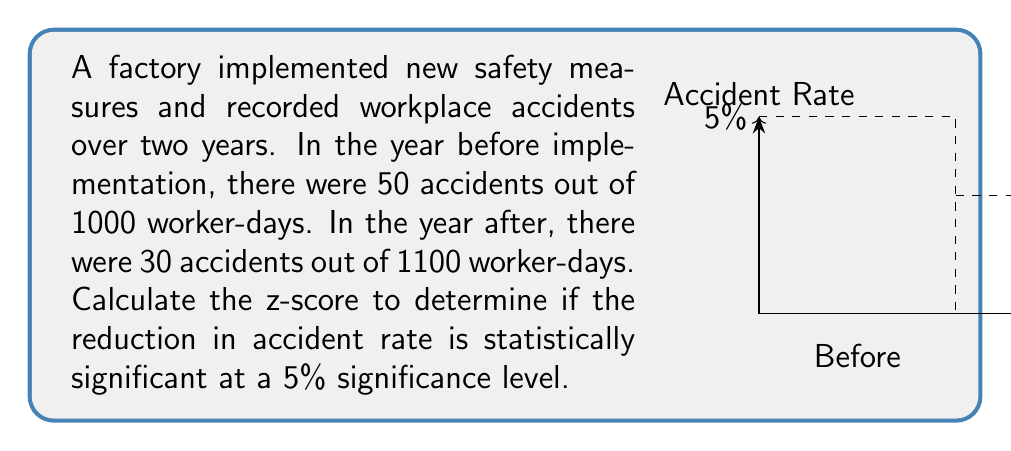Help me with this question. To determine if the reduction in accident rate is statistically significant, we'll use a z-test for the difference between two proportions.

Step 1: Calculate the proportions
$p_1 = 50/1000 = 0.05$ (before)
$p_2 = 30/1100 \approx 0.0273$ (after)

Step 2: Calculate the pooled proportion
$$p = \frac{50 + 30}{1000 + 1100} \approx 0.0381$$

Step 3: Calculate the standard error
$$SE = \sqrt{p(1-p)(\frac{1}{1000} + \frac{1}{1100})} \approx 0.00812$$

Step 4: Calculate the z-score
$$z = \frac{p_1 - p_2}{SE} = \frac{0.05 - 0.0273}{0.00812} \approx 2.795$$

Step 5: Compare with critical value
For a 5% significance level (two-tailed test), the critical z-value is 1.96.

Since $2.795 > 1.96$, we reject the null hypothesis.
Answer: $z \approx 2.795$; statistically significant reduction 